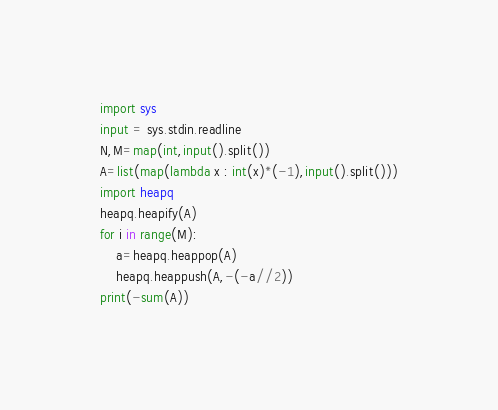<code> <loc_0><loc_0><loc_500><loc_500><_Python_>import sys
input = sys.stdin.readline
N,M=map(int,input().split())
A=list(map(lambda x : int(x)*(-1),input().split()))
import heapq
heapq.heapify(A)
for i in range(M):
    a=heapq.heappop(A)
    heapq.heappush(A,-(-a//2))
print(-sum(A))
</code> 